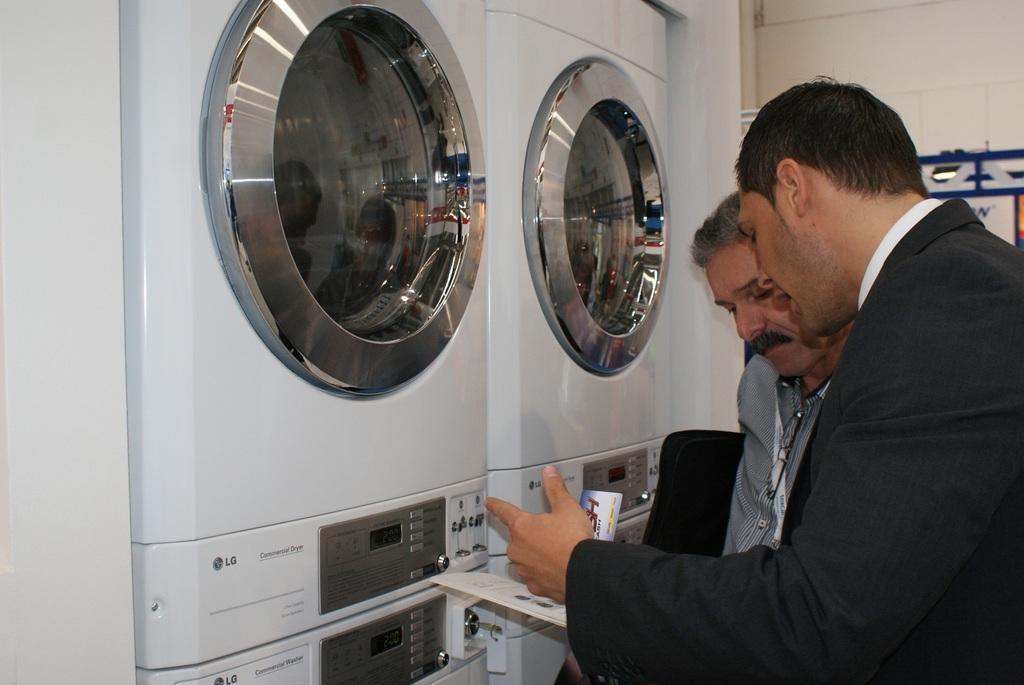Describe this image in one or two sentences. In this picture we can see two men on the right side, a person in the front is holding a paper, on the left side there are washing machines, in the background there is a wall. 